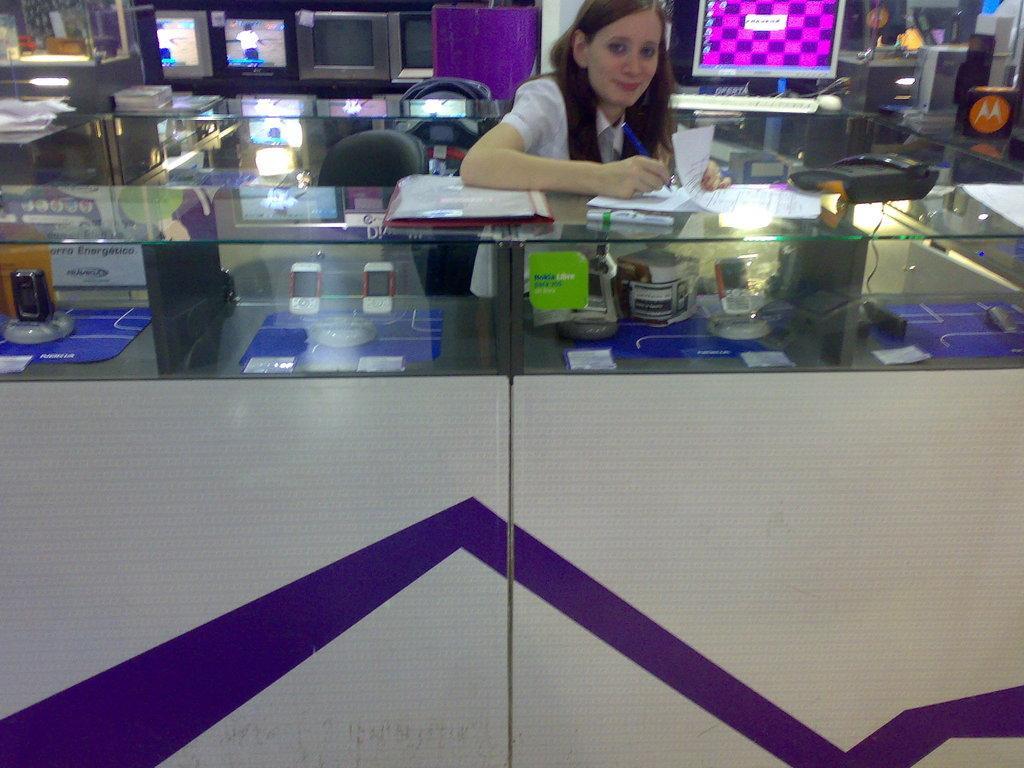How would you summarize this image in a sentence or two? In this picture there is a woman is smiling and she is writing and there are papers and there are objects and there is a telephone on the table and there are devices and objects under the table. At the back there are devices and there are chairs and wires on the table and there are pictures of persons on the screens. 